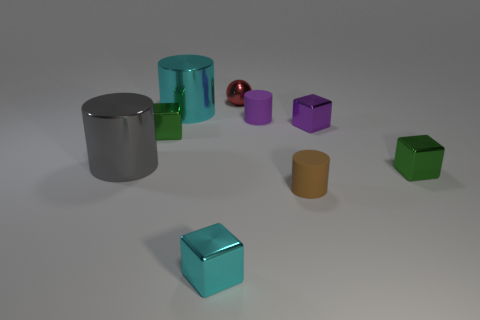Subtract all tiny purple metal cubes. How many cubes are left? 3 Add 1 big gray shiny things. How many objects exist? 10 Subtract all cyan blocks. How many blocks are left? 3 Subtract all cubes. How many objects are left? 5 Subtract all purple cylinders. How many green cubes are left? 2 Subtract all green blocks. Subtract all blocks. How many objects are left? 3 Add 9 big cyan metallic objects. How many big cyan metallic objects are left? 10 Add 4 balls. How many balls exist? 5 Subtract 0 purple balls. How many objects are left? 9 Subtract 2 cylinders. How many cylinders are left? 2 